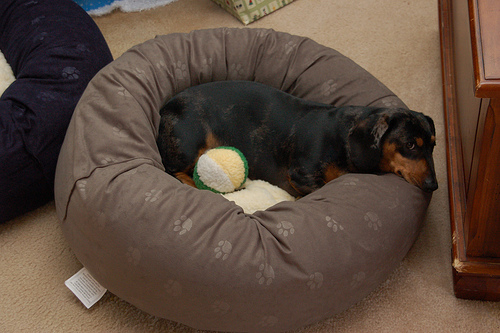<image>
Is there a ball on the dog? Yes. Looking at the image, I can see the ball is positioned on top of the dog, with the dog providing support. Is the dog behind the ball? Yes. From this viewpoint, the dog is positioned behind the ball, with the ball partially or fully occluding the dog. 